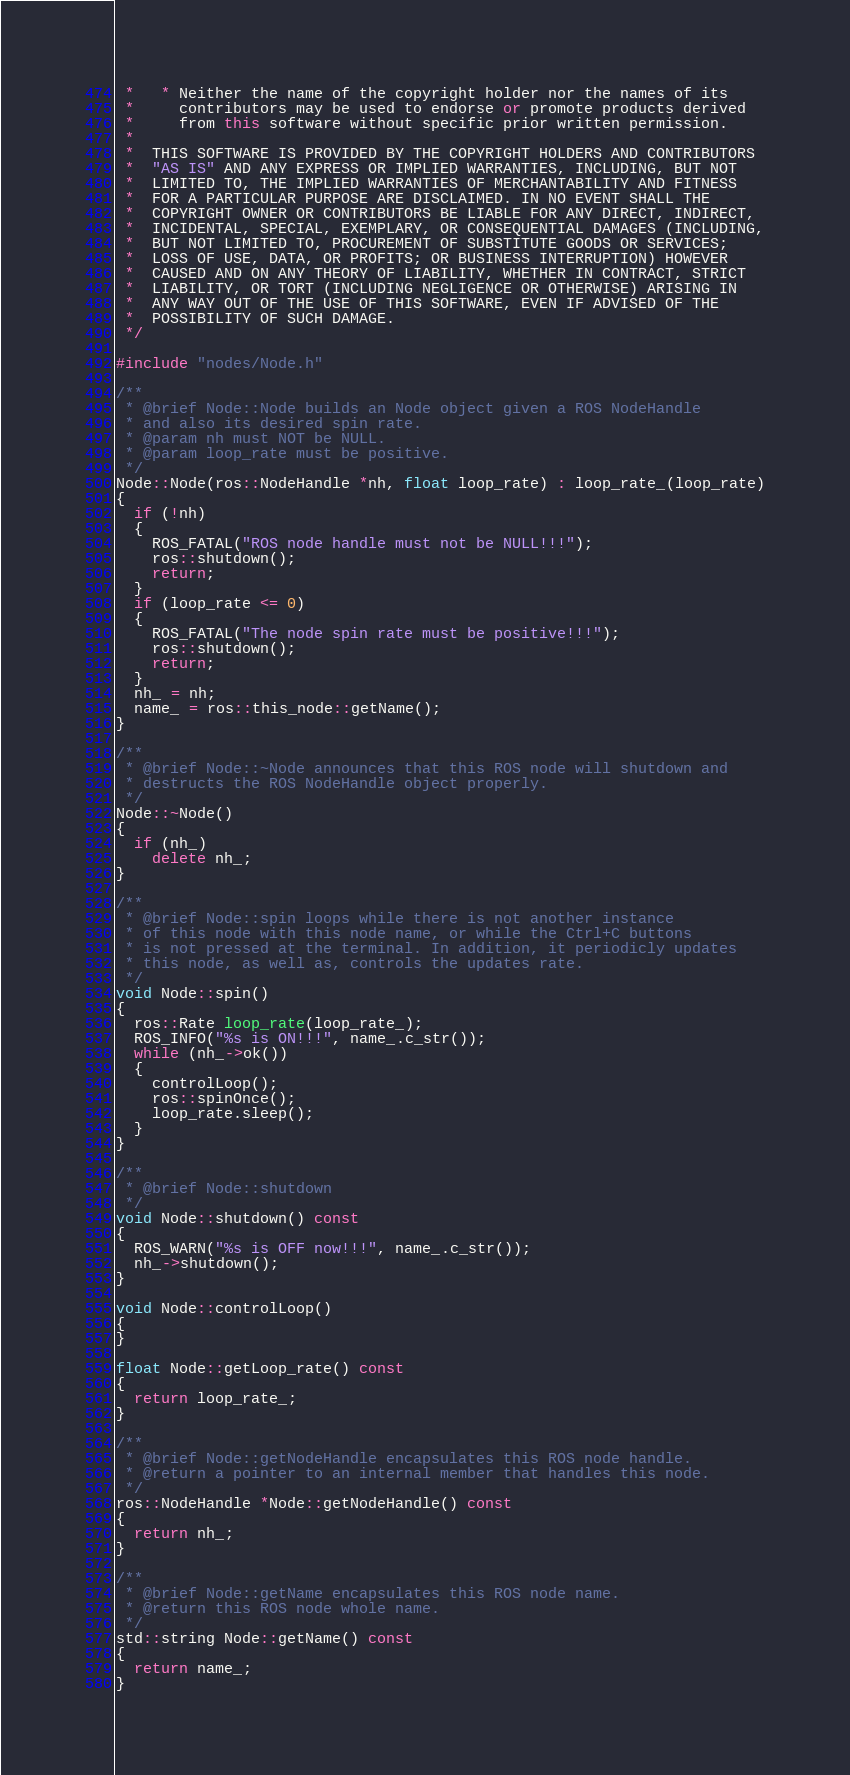Convert code to text. <code><loc_0><loc_0><loc_500><loc_500><_C++_> *   * Neither the name of the copyright holder nor the names of its
 *     contributors may be used to endorse or promote products derived
 *     from this software without specific prior written permission.
 *
 *  THIS SOFTWARE IS PROVIDED BY THE COPYRIGHT HOLDERS AND CONTRIBUTORS
 *  "AS IS" AND ANY EXPRESS OR IMPLIED WARRANTIES, INCLUDING, BUT NOT
 *  LIMITED TO, THE IMPLIED WARRANTIES OF MERCHANTABILITY AND FITNESS
 *  FOR A PARTICULAR PURPOSE ARE DISCLAIMED. IN NO EVENT SHALL THE
 *  COPYRIGHT OWNER OR CONTRIBUTORS BE LIABLE FOR ANY DIRECT, INDIRECT,
 *  INCIDENTAL, SPECIAL, EXEMPLARY, OR CONSEQUENTIAL DAMAGES (INCLUDING,
 *  BUT NOT LIMITED TO, PROCUREMENT OF SUBSTITUTE GOODS OR SERVICES;
 *  LOSS OF USE, DATA, OR PROFITS; OR BUSINESS INTERRUPTION) HOWEVER
 *  CAUSED AND ON ANY THEORY OF LIABILITY, WHETHER IN CONTRACT, STRICT
 *  LIABILITY, OR TORT (INCLUDING NEGLIGENCE OR OTHERWISE) ARISING IN
 *  ANY WAY OUT OF THE USE OF THIS SOFTWARE, EVEN IF ADVISED OF THE
 *  POSSIBILITY OF SUCH DAMAGE.
 */

#include "nodes/Node.h"

/**
 * @brief Node::Node builds an Node object given a ROS NodeHandle
 * and also its desired spin rate.
 * @param nh must NOT be NULL.
 * @param loop_rate must be positive.
 */
Node::Node(ros::NodeHandle *nh, float loop_rate) : loop_rate_(loop_rate)
{
  if (!nh)
  {
    ROS_FATAL("ROS node handle must not be NULL!!!");
    ros::shutdown();
    return;
  }
  if (loop_rate <= 0)
  {
    ROS_FATAL("The node spin rate must be positive!!!");
    ros::shutdown();
    return;
  }
  nh_ = nh;
  name_ = ros::this_node::getName();
}

/**
 * @brief Node::~Node announces that this ROS node will shutdown and
 * destructs the ROS NodeHandle object properly.
 */
Node::~Node()
{
  if (nh_)
    delete nh_;
}

/**
 * @brief Node::spin loops while there is not another instance
 * of this node with this node name, or while the Ctrl+C buttons
 * is not pressed at the terminal. In addition, it periodicly updates
 * this node, as well as, controls the updates rate.
 */
void Node::spin()
{
  ros::Rate loop_rate(loop_rate_);
  ROS_INFO("%s is ON!!!", name_.c_str());
  while (nh_->ok())
  {
    controlLoop();
    ros::spinOnce();
    loop_rate.sleep();
  }
}

/**
 * @brief Node::shutdown
 */
void Node::shutdown() const
{
  ROS_WARN("%s is OFF now!!!", name_.c_str());
  nh_->shutdown();
}

void Node::controlLoop()
{
}

float Node::getLoop_rate() const
{
  return loop_rate_;
}

/**
 * @brief Node::getNodeHandle encapsulates this ROS node handle.
 * @return a pointer to an internal member that handles this node.
 */
ros::NodeHandle *Node::getNodeHandle() const
{
  return nh_;
}

/**
 * @brief Node::getName encapsulates this ROS node name.
 * @return this ROS node whole name.
 */
std::string Node::getName() const
{
  return name_;
}
</code> 